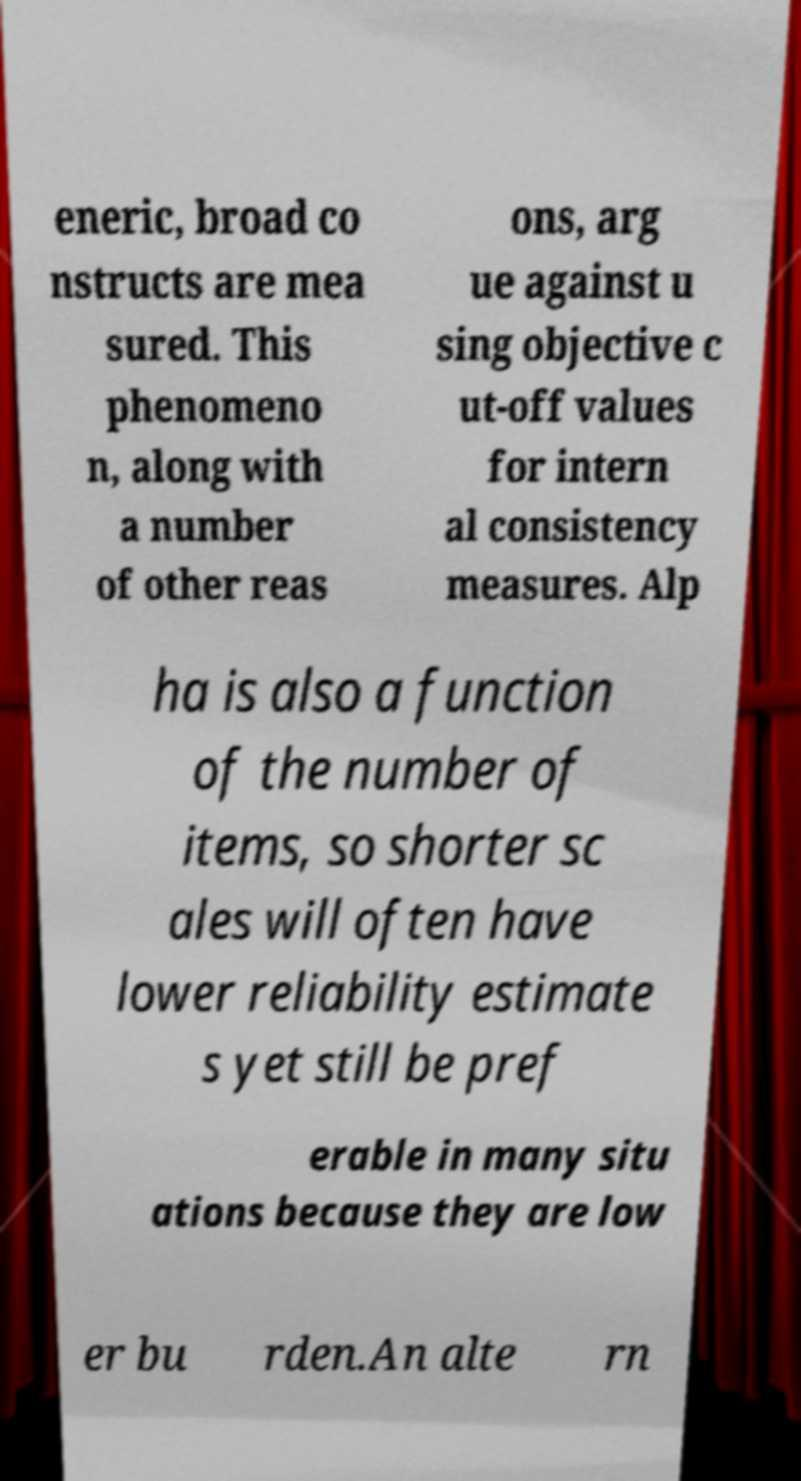Can you accurately transcribe the text from the provided image for me? eneric, broad co nstructs are mea sured. This phenomeno n, along with a number of other reas ons, arg ue against u sing objective c ut-off values for intern al consistency measures. Alp ha is also a function of the number of items, so shorter sc ales will often have lower reliability estimate s yet still be pref erable in many situ ations because they are low er bu rden.An alte rn 